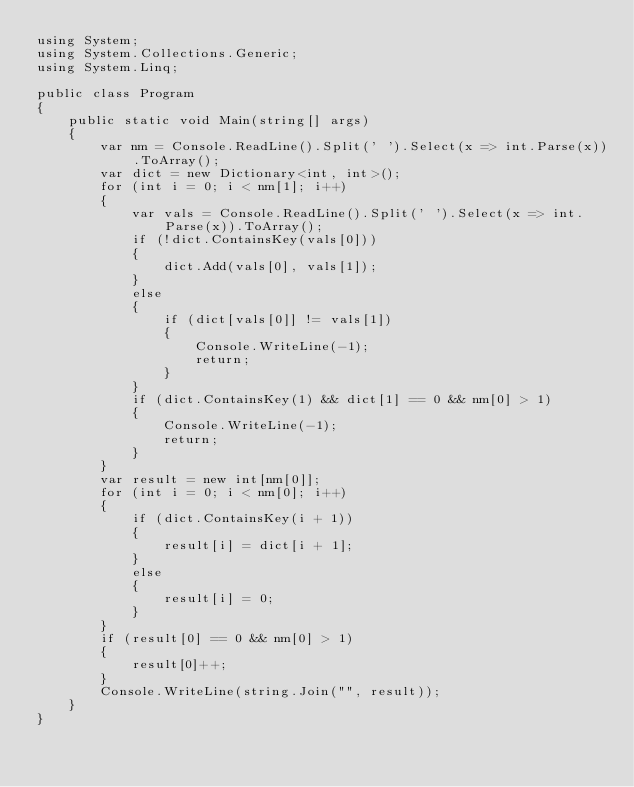<code> <loc_0><loc_0><loc_500><loc_500><_C#_>using System;
using System.Collections.Generic;
using System.Linq;

public class Program
{
    public static void Main(string[] args)
    {
        var nm = Console.ReadLine().Split(' ').Select(x => int.Parse(x)).ToArray();
        var dict = new Dictionary<int, int>();
        for (int i = 0; i < nm[1]; i++)
        {
            var vals = Console.ReadLine().Split(' ').Select(x => int.Parse(x)).ToArray();
            if (!dict.ContainsKey(vals[0]))
            {
                dict.Add(vals[0], vals[1]);
            }
            else
            {
                if (dict[vals[0]] != vals[1])
                {
                    Console.WriteLine(-1);
                    return;
                }
            }
            if (dict.ContainsKey(1) && dict[1] == 0 && nm[0] > 1)
            {
                Console.WriteLine(-1);
                return;
            }
        }
        var result = new int[nm[0]];
        for (int i = 0; i < nm[0]; i++)
        {
            if (dict.ContainsKey(i + 1))
            {
                result[i] = dict[i + 1];
            }
            else
            {
                result[i] = 0;
            }
        }
        if (result[0] == 0 && nm[0] > 1)
        {
            result[0]++;
        }
        Console.WriteLine(string.Join("", result));
    }
}</code> 